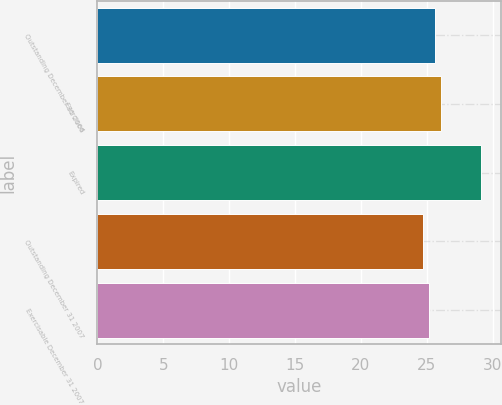Convert chart. <chart><loc_0><loc_0><loc_500><loc_500><bar_chart><fcel>Outstanding December 31 2006<fcel>Exercised<fcel>Expired<fcel>Outstanding December 31 2007<fcel>Exercisable December 31 2007<nl><fcel>25.59<fcel>26.04<fcel>29.15<fcel>24.69<fcel>25.14<nl></chart> 